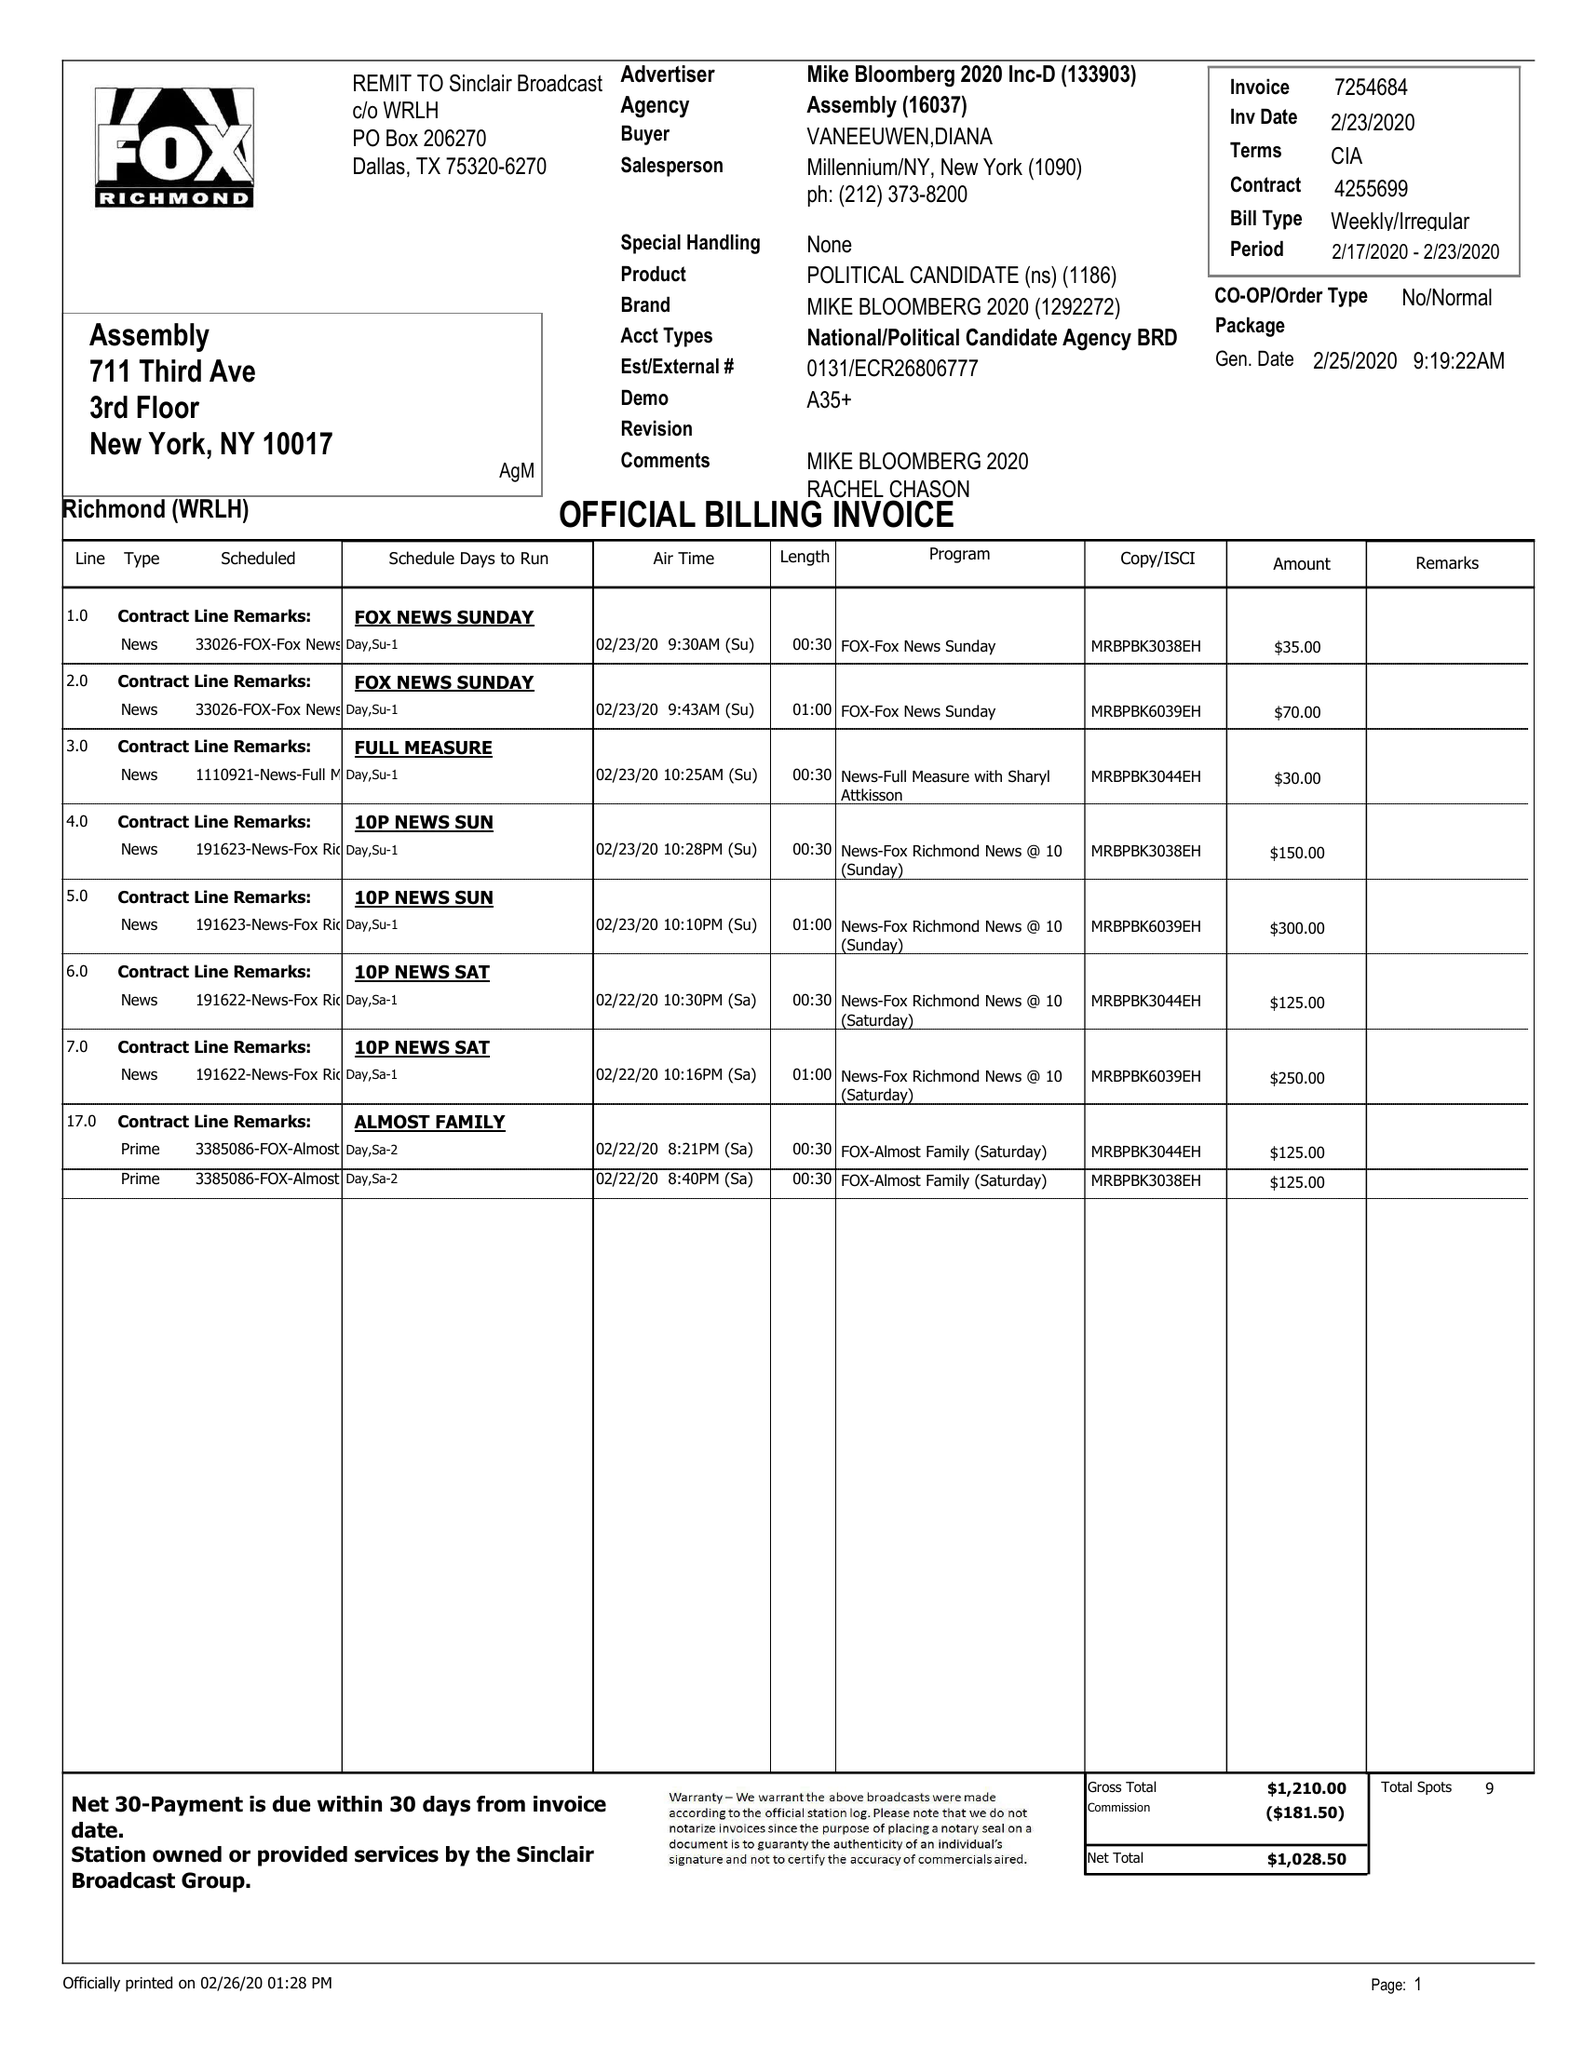What is the value for the contract_num?
Answer the question using a single word or phrase. 4255699 